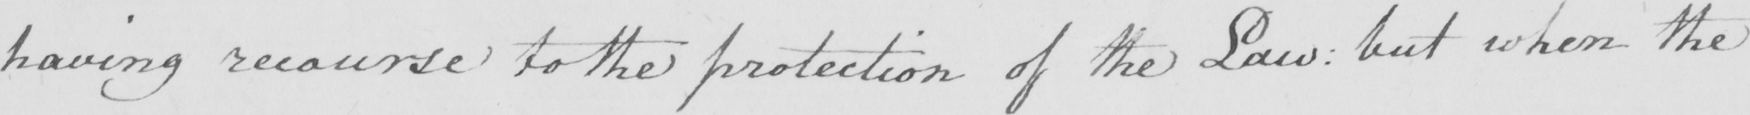What text is written in this handwritten line? having recourse to the protection of the Law :  but when the 